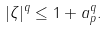Convert formula to latex. <formula><loc_0><loc_0><loc_500><loc_500>| \zeta | ^ { q } \leq 1 + \| a \| _ { p } ^ { q } .</formula> 